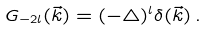<formula> <loc_0><loc_0><loc_500><loc_500>G _ { - 2 l } ( \vec { k } ) = ( - \triangle ) ^ { l } \delta ( \vec { k } ) \, .</formula> 